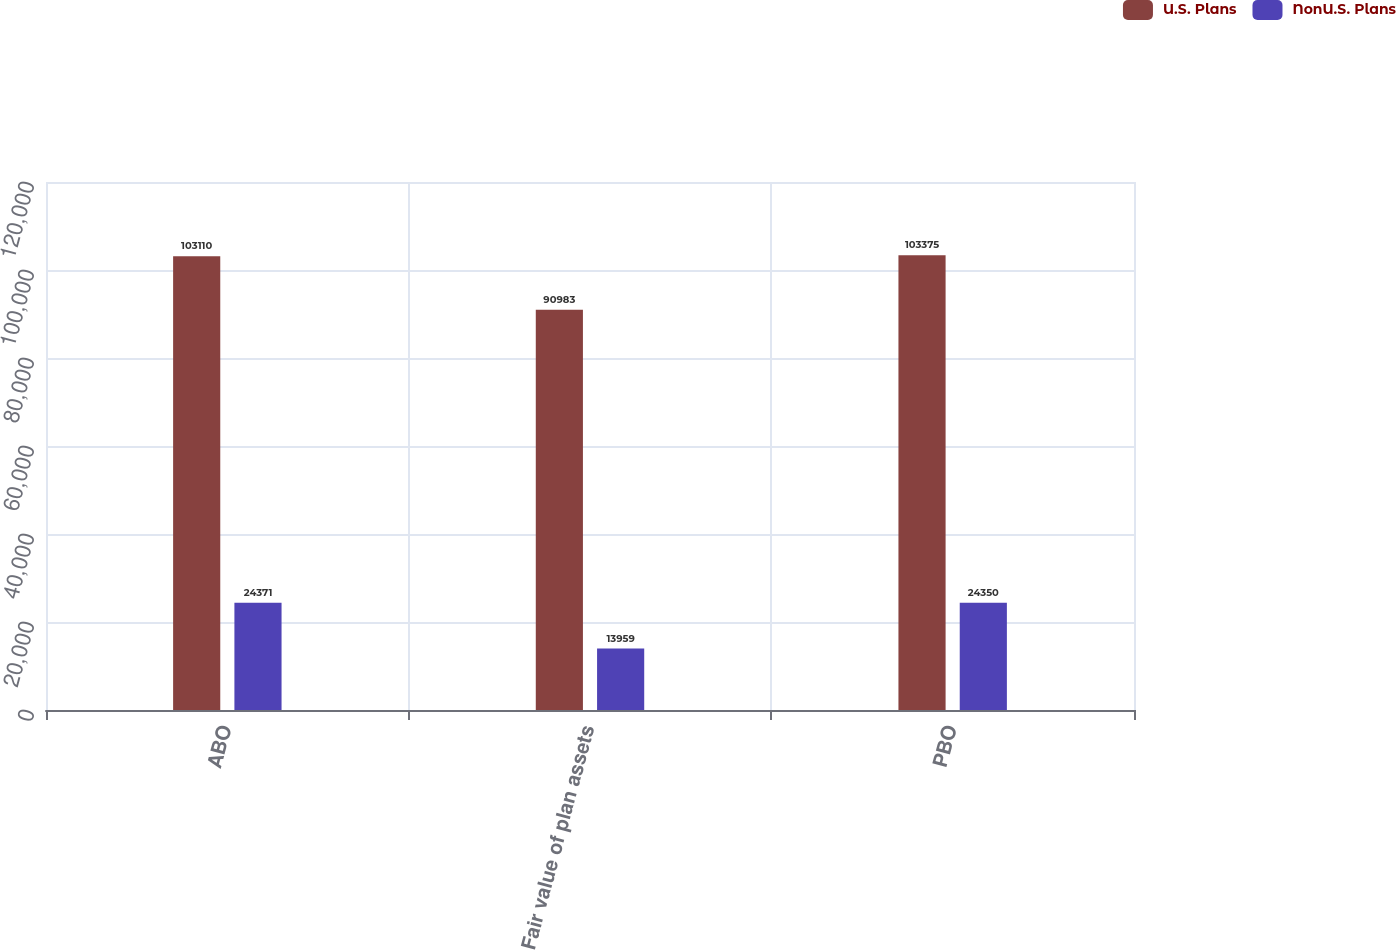Convert chart. <chart><loc_0><loc_0><loc_500><loc_500><stacked_bar_chart><ecel><fcel>ABO<fcel>Fair value of plan assets<fcel>PBO<nl><fcel>U.S. Plans<fcel>103110<fcel>90983<fcel>103375<nl><fcel>NonU.S. Plans<fcel>24371<fcel>13959<fcel>24350<nl></chart> 